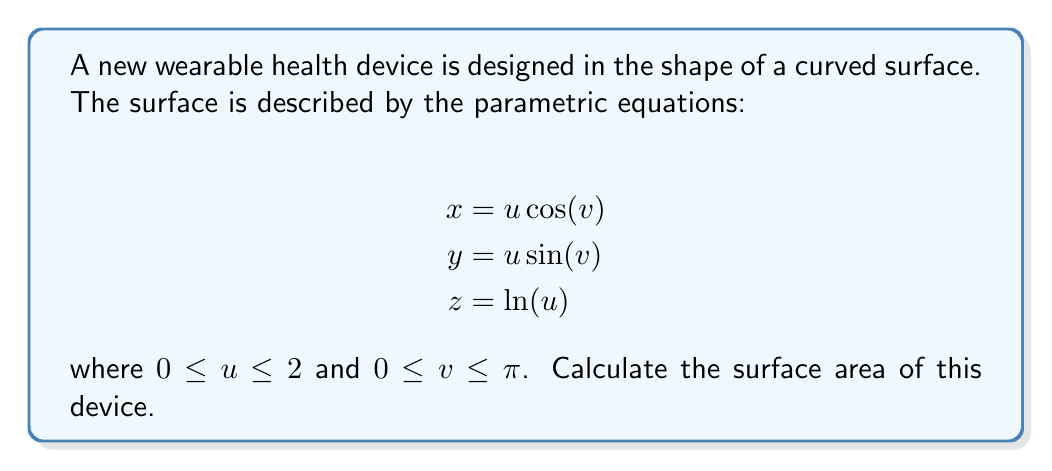Can you answer this question? To calculate the surface area using parametric equations, we need to follow these steps:

1) First, we need to find the partial derivatives of x, y, and z with respect to u and v:

   $$\frac{\partial x}{\partial u} = \cos(v), \frac{\partial x}{\partial v} = -u\sin(v)$$
   $$\frac{\partial y}{\partial u} = \sin(v), \frac{\partial y}{\partial v} = u\cos(v)$$
   $$\frac{\partial z}{\partial u} = \frac{1}{u}, \frac{\partial z}{\partial v} = 0$$

2) Next, we calculate the cross product of these partial derivatives:

   $$\left|\frac{\partial \mathbf{r}}{\partial u} \times \frac{\partial \mathbf{r}}{\partial v}\right| = \left|\begin{vmatrix} 
   \mathbf{i} & \mathbf{j} & \mathbf{k} \\
   \cos(v) & \sin(v) & \frac{1}{u} \\
   -u\sin(v) & u\cos(v) & 0
   \end{vmatrix}\right|$$

3) Evaluating this determinant:

   $$\left|\frac{\partial \mathbf{r}}{\partial u} \times \frac{\partial \mathbf{r}}{\partial v}\right| = \sqrt{u^2\cos^2(v) + u^2\sin^2(v) + 1} = \sqrt{u^2 + 1}$$

4) The surface area is given by the double integral:

   $$A = \int_0^\pi \int_0^2 \sqrt{u^2 + 1} \, du \, dv$$

5) Evaluating the inner integral:

   $$\int_0^2 \sqrt{u^2 + 1} \, du = \frac{1}{2}[u\sqrt{u^2+1} + \ln(u+\sqrt{u^2+1})]_0^2$$
   $$= \frac{1}{2}[2\sqrt{5} + \ln(2+\sqrt{5})]$$

6) The outer integral is simply multiplication by $\pi$ due to the limits of v:

   $$A = \frac{\pi}{2}[2\sqrt{5} + \ln(2+\sqrt{5})]$$
Answer: $$\frac{\pi}{2}[2\sqrt{5} + \ln(2+\sqrt{5})]$$ 